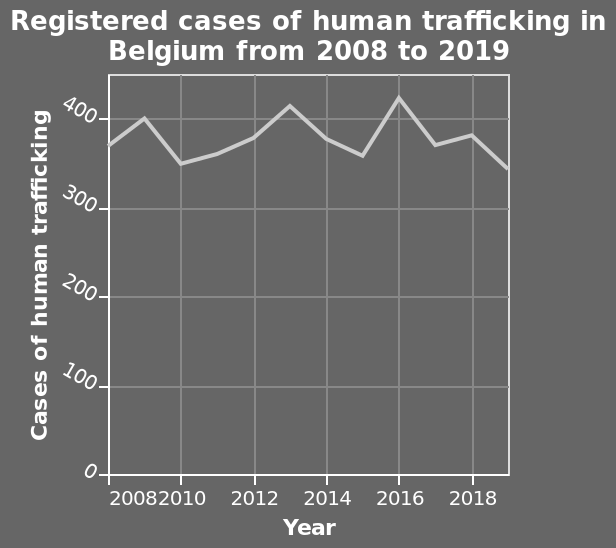<image>
What period does the line diagram cover? The line diagram covers the years from 2008 to 2019. How many registered cases of human trafficking were there in 2017? 380 cases. 